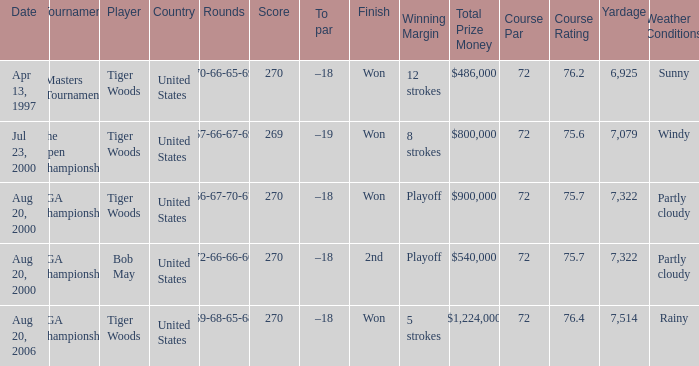What days were the rounds of 66-67-70-67 recorded? Aug 20, 2000. 